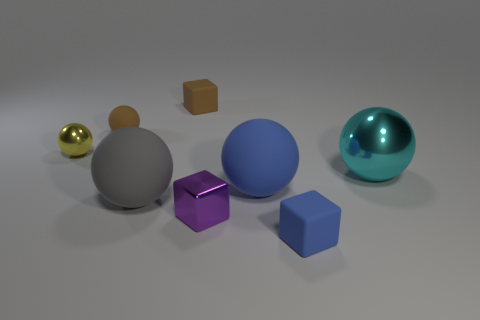How many other objects are there of the same material as the large cyan sphere?
Ensure brevity in your answer.  2. The small object that is both on the right side of the small yellow metallic sphere and left of the large gray rubber object has what shape?
Offer a terse response. Sphere. Do the tiny matte ball and the cube that is behind the yellow metallic object have the same color?
Keep it short and to the point. Yes. There is a matte cube on the left side of the purple shiny cube; is its size the same as the gray thing?
Offer a very short reply. No. There is a yellow thing that is the same shape as the gray rubber thing; what is it made of?
Offer a very short reply. Metal. Does the yellow metallic thing have the same shape as the small blue thing?
Offer a very short reply. No. There is a small rubber cube that is left of the small purple metallic thing; what number of yellow objects are behind it?
Make the answer very short. 0. What shape is the cyan object that is made of the same material as the purple block?
Offer a very short reply. Sphere. How many purple objects are either metallic cylinders or tiny metal blocks?
Offer a terse response. 1. Is there a tiny shiny sphere that is behind the big cyan sphere that is to the right of the small shiny thing that is behind the big blue thing?
Ensure brevity in your answer.  Yes. 